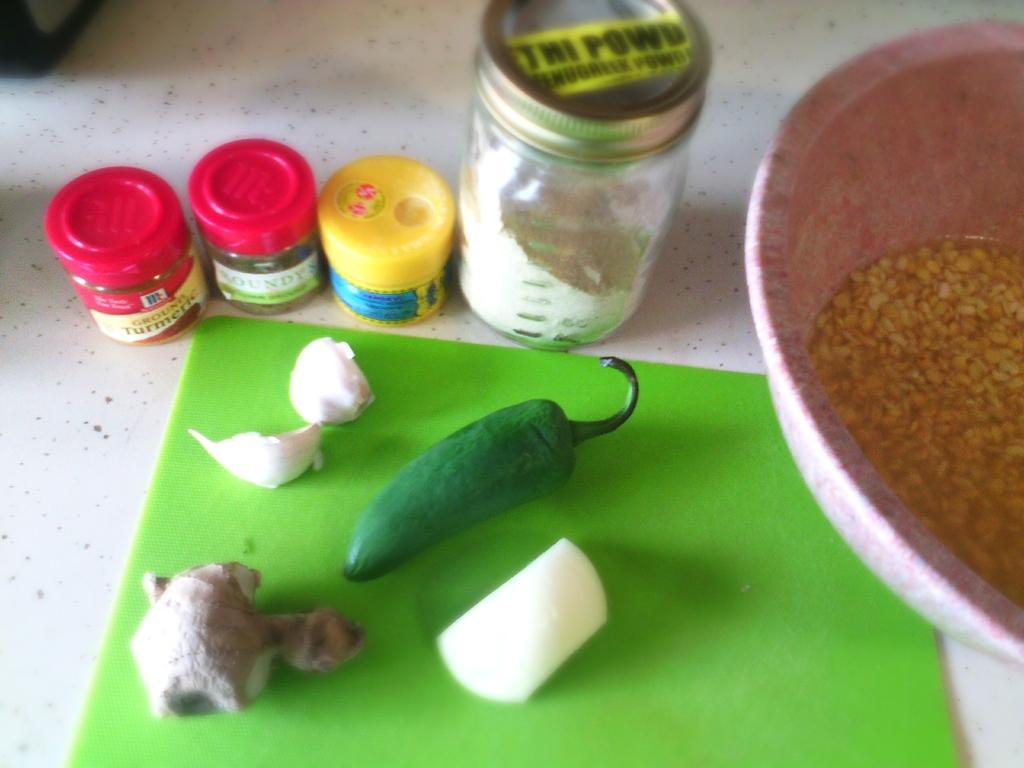What type of vegetables are present in the image? There are green chillies, garlic, ginger, and an onion in the image. What other items can be seen in the image besides vegetables? There are jars and a bowl with grains in the background of the image. Can you see a rat holding a veil in the image? No, there is no rat or veil present in the image. 